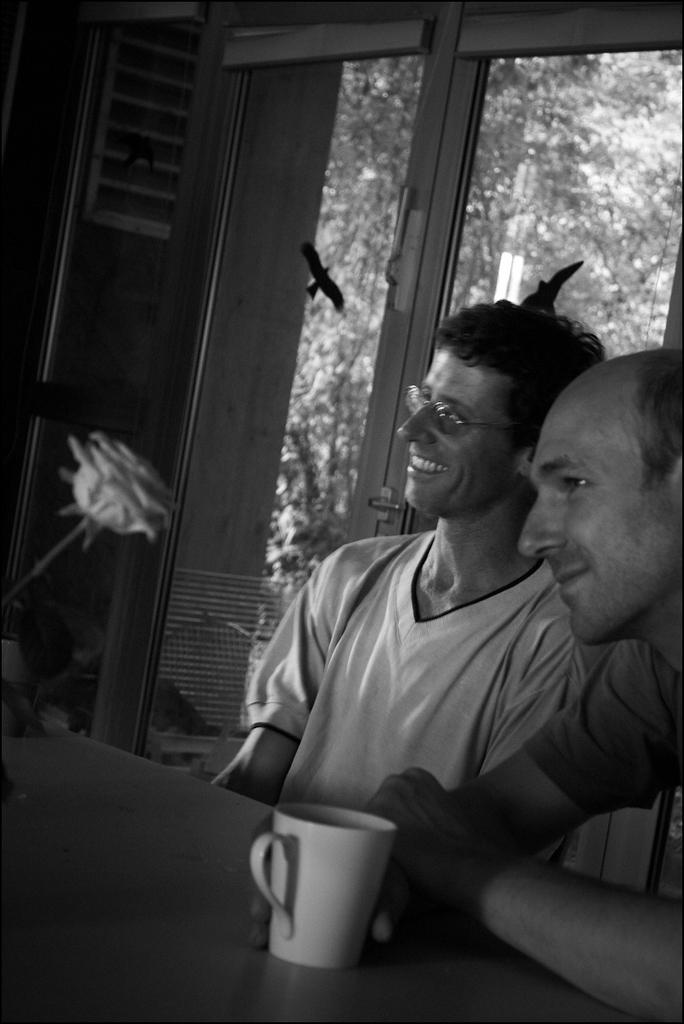How many people are in the image? There are two men in the image. What is one of the men holding? One man is holding a cup. Where is the cup located? The cup is on a table. What can be seen in the background of the image? There is a window in the background of the image. What is visible through the window? There is a tree visible through the window. What type of patch is sewn onto the man's shirt in the image? There is no patch visible on the man's shirt in the image. How many frogs are hopping around the table in the image? There are no frogs present in the image. 